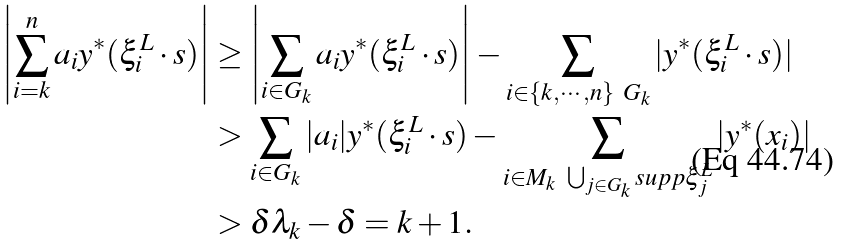<formula> <loc_0><loc_0><loc_500><loc_500>\left | \sum _ { i = k } ^ { n } a _ { i } y ^ { * } ( { \xi } _ { i } ^ { L } \cdot s ) \right | & \geq \left | \sum _ { i \in G _ { k } } a _ { i } y ^ { * } ( { \xi } _ { i } ^ { L } \cdot s ) \right | - \sum _ { i \in \{ k , \cdots , n \} \ G _ { k } } | y ^ { * } ( { \xi } _ { i } ^ { L } \cdot s ) | \\ & > \sum _ { i \in G _ { k } } | a _ { i } | y ^ { * } ( { \xi } _ { i } ^ { L } \cdot s ) - \sum _ { i \in M _ { k } \ \bigcup _ { j \in G _ { k } } s u p p { \xi } _ { j } ^ { L } } | y ^ { * } ( x _ { i } ) | \\ & > { \delta } { { \lambda } _ { k } } - \delta = k + 1 .</formula> 